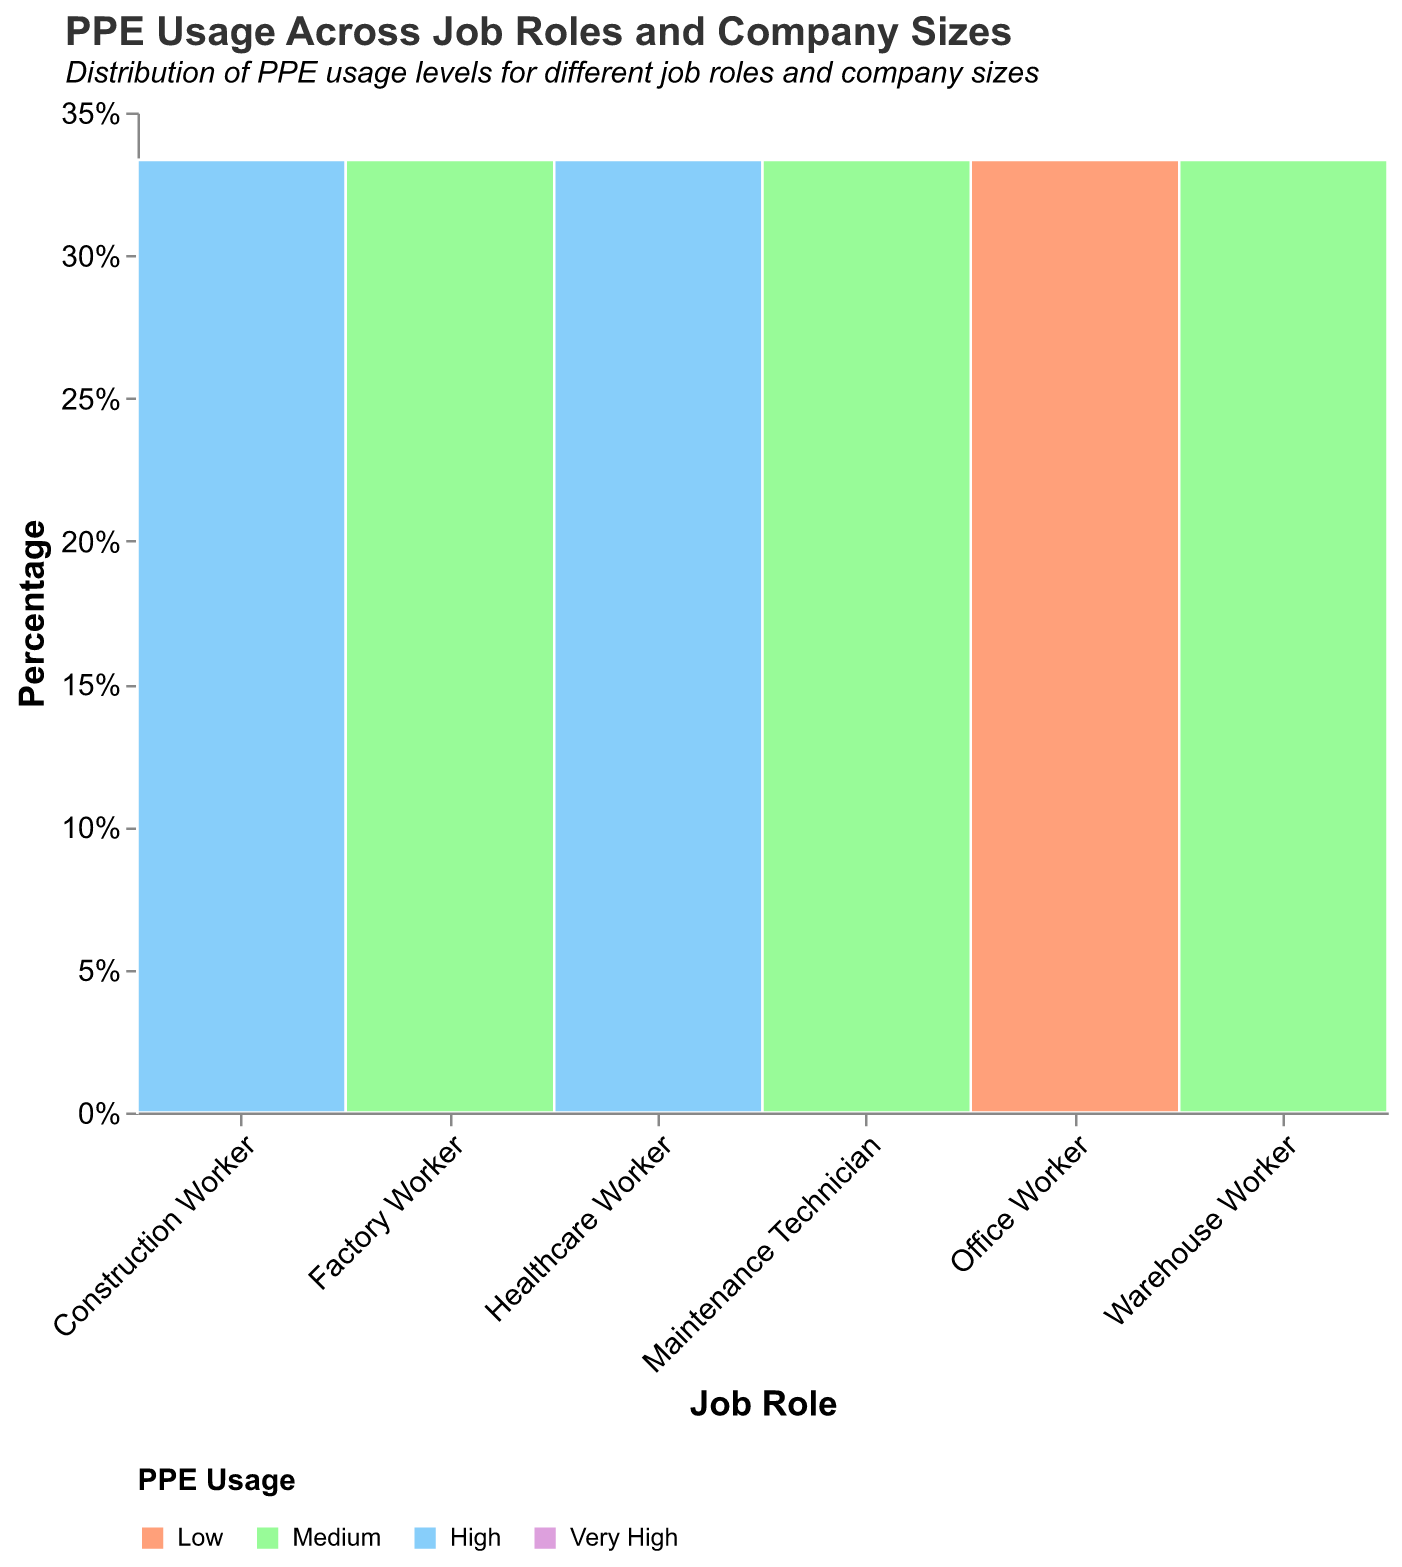What is the predominant PPE usage level for Office Workers? The color indicating 'Low' PPE usage appears frequently in the sections for Office Workers. From the legend, the color for 'Low' is seen in both small and medium company sizes, while 'Medium' PPE usage shows up in large companies.
Answer: Low How does PPE usage change for Construction Workers in Small versus Large companies? For Construction Workers, the color indicating 'High' is seen in small and medium companies, transitioning to 'Very High' in large companies. This shows an increase in PPE usage from high to very high as company size increases.
Answer: Increases Which job role has the highest level of PPE usage in medium-sized companies? By examining the middle column of each job role, the Healthcare Worker section is predominately filled with the color indicating 'Very High' usage, more than any other job role in medium-sized companies.
Answer: Healthcare Worker Compare the PPE usage of Factory Workers to Warehouse Workers in small companies. For Factory Workers in small companies, the color indicating 'Medium' PPE usage is predominant. Conversely, in the Warehouse Worker section for small companies, 'Medium' PPE usage is also observed. Both roles have the same level of PPE usage.
Answer: Same How is the distribution of PPE usage among Warehouse Workers across different company sizes? For Warehouse Workers, 'Medium' PPE usage is seen in small companies, while 'High' PPE usage is evident in both medium and large companies. There is no 'Low' or 'Very High' PPE usage for this job role.
Answer: Medium in small, High in medium and large What pattern is observed in PPE usage for Healthcare Workers as company size increases? Healthcare Workers show 'High' PPE usage in small companies, and 'Very High' PPE usage consistently in medium and large companies. This indicates an increase to very high levels as company size grows.
Answer: Increase to Very High Which job role exhibits the most variation in PPE usage levels across different company sizes? The color distribution for Office Workers spans from 'Low' in small and medium companies to 'Medium' in large companies. Other job roles tend to have more consistent PPE usage levels across company sizes.
Answer: Office Worker What's the ratio of 'Very High' PPE usage to 'High' PPE usage for Construction Workers? Construction Workers show 'Very High' PPE usage in large companies and 'High' in small and medium companies. Thus, the 'Very High' to 'High' ratio is 1:2.
Answer: 1:2 Are there any job roles that do not use 'Low' PPE usage at any company size? Construction Worker, Factory Worker, Healthcare Worker, Warehouse Worker, and Maintenance Technician do not have any sections colored to indicate 'Low' PPE usage in any company size.
Answer: Yes 